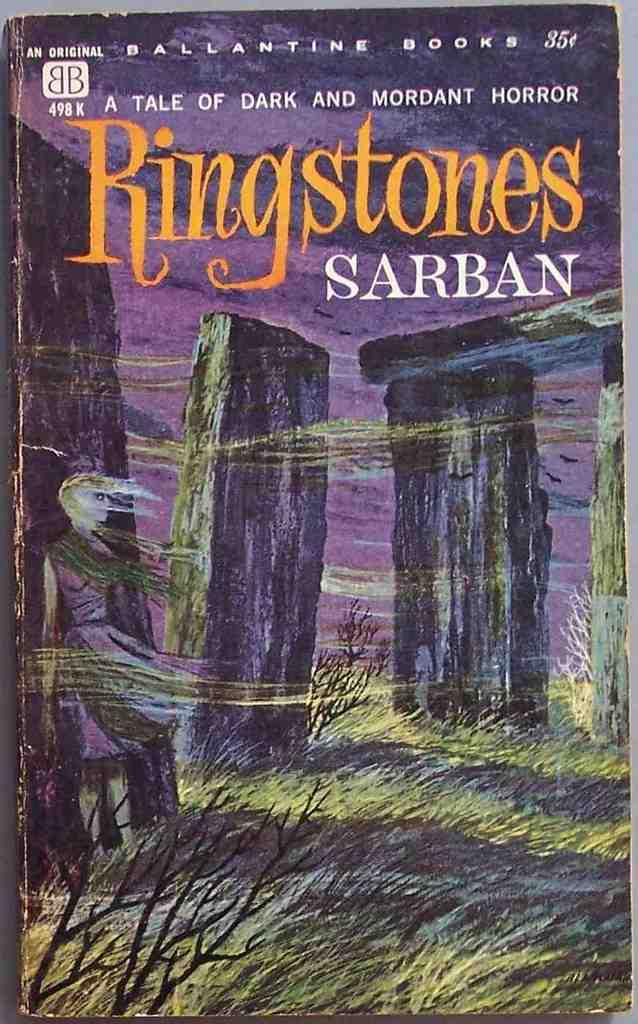<image>
Render a clear and concise summary of the photo. a book that has ringstones on the front 